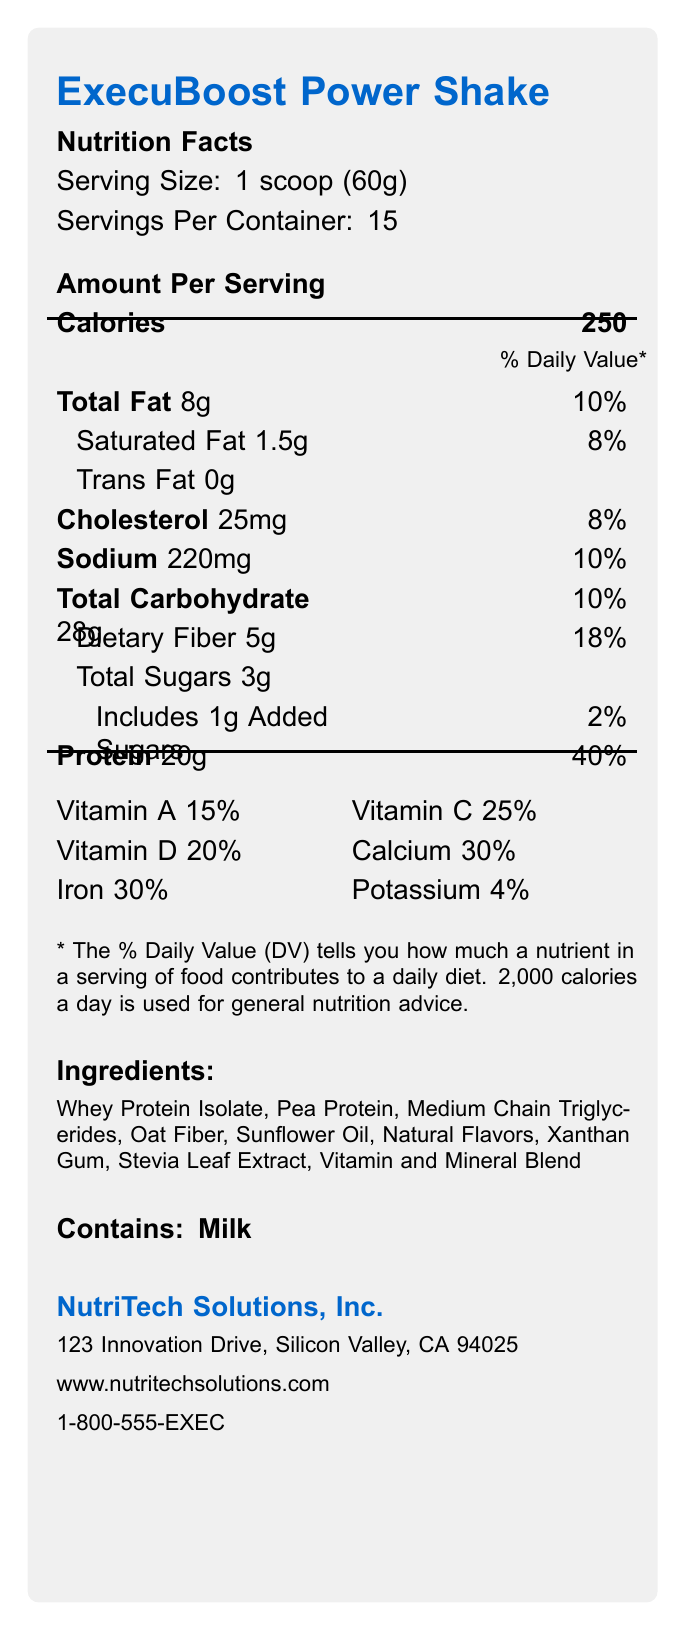what is the serving size for the ExecuBoost Power Shake? The serving size is stated as "1 scoop (60g)" on the document.
Answer: 1 scoop (60g) how many calories are in one serving of the shake? The document specifies that the shake contains 250 calories per serving.
Answer: 250 what is the total fat content per serving? The total fat content per serving is listed as 8 grams.
Answer: 8g how much protein does each serving contain? Each serving contains 20 grams of protein.
Answer: 20g what type of ingredients does the shake contain? The ingredients are listed in the document under the "Ingredients" section.
Answer: Whey Protein Isolate, Pea Protein, Medium Chain Triglycerides, Oat Fiber, Sunflower Oil, Natural Flavors, Xanthan Gum, Stevia Leaf Extract, Vitamin and Mineral Blend how many servings are there per container? The document states that there are 15 servings per container.
Answer: 15 what is the daily value percentage of dietary fiber per serving? The daily value percentage of dietary fiber per serving is 18%.
Answer: 18% what company manufactures the ExecuBoost Power Shake? The manufacturer, NutriTech Solutions, Inc., is indicated under the manufacturer info.
Answer: NutriTech Solutions, Inc. which of the following claims are made about the ExecuBoost Power Shake? A. High in protein B. Contains artificial sweeteners C. Supports cognitive function D. Enhances energy and focus The claims made in the document include "High in protein", "Supports cognitive function", and "Enhances energy and focus". There is a claim about no artificial sweeteners, so option B is incorrect.
Answer: A, C, D which vitamins in the shake exceed a 30% daily value per serving? A. Vitamin A B. Vitamin K C. Folate D. Vitamin B12 E. Vitamin E Both Folate (50%) and Vitamin B12 (50%) exceed a 30% daily value per serving.
Answer: C, D is the ExecuBoost Power Shake suitable for someone with a milk allergy? The document indicates that the shake contains milk, making it unsuitable for someone with a milk allergy.
Answer: No describe the main idea of the ExecuBoost Power Shake's nutrition facts label. This label provides all the necessary nutritional information and additional claims to ensure that consumers understand the benefits and content of the product.
Answer: The nutrition facts label for the ExecuBoost Power Shake provides detailed information about its nutritional content, including serving size, caloric value, macronutrient levels, vitamins, and minerals. It highlights the product's high protein, good fiber content, and benefits such as supporting cognitive function and enhancing energy and focus. The label also lists the ingredients, allergen information, and manufacturer details. what is the exact amount of trans fat in the shake? The document lists the trans fat content as 0 grams.
Answer: 0g how much calcium is present in one serving of the drink? The document shows a daily value percentage of 30% for calcium per serving.
Answer: 30% what storage instructions are given for the shake? The storage instructions are mentioned under the "storage instructions" section.
Answer: Store in a cool, dry place. Consume within 30 days after opening. which of the following cannot be determined from the nutrition facts label? A. The flavor of the shake B. The manufacturer contact number C. The percentage of magnesium D. The ingredient proportions The label provides ingredient names but does not specify their proportions, making option D the correct answer.
Answer: D 